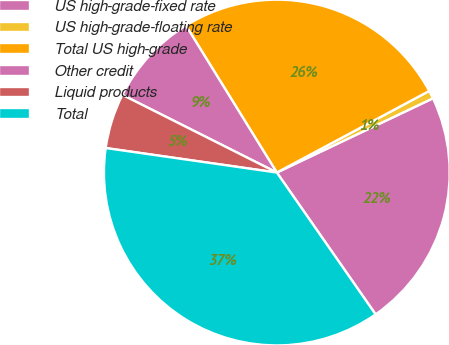Convert chart to OTSL. <chart><loc_0><loc_0><loc_500><loc_500><pie_chart><fcel>US high-grade-fixed rate<fcel>US high-grade-floating rate<fcel>Total US high-grade<fcel>Other credit<fcel>Liquid products<fcel>Total<nl><fcel>22.38%<fcel>0.76%<fcel>25.99%<fcel>8.77%<fcel>5.15%<fcel>36.94%<nl></chart> 